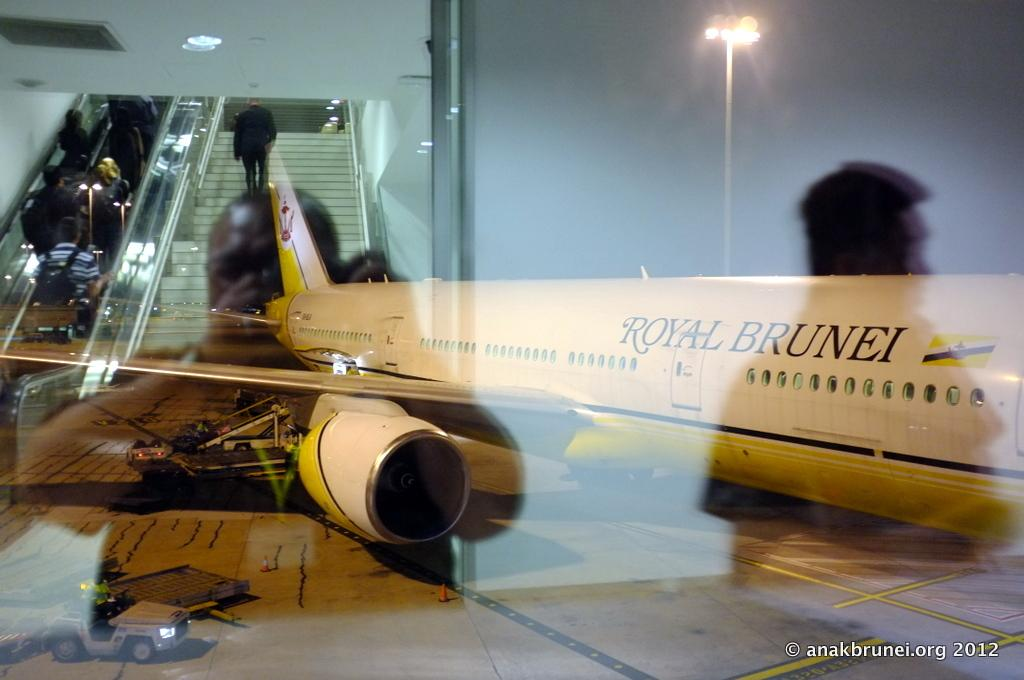<image>
Give a short and clear explanation of the subsequent image. A royal Brunei plane is parked at the baording gate. 